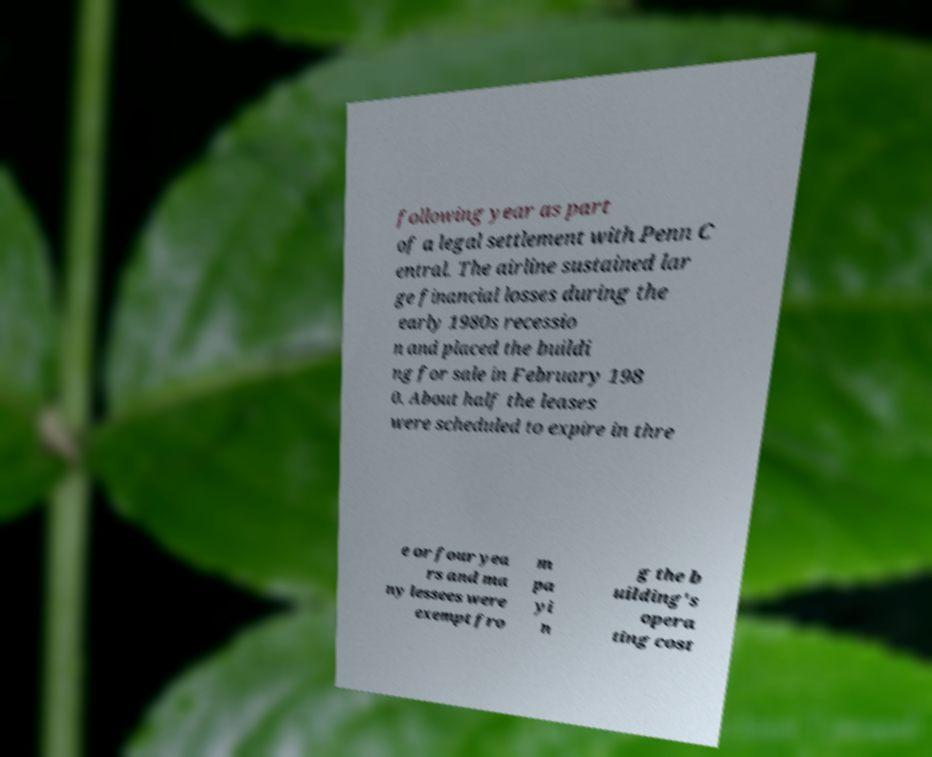Please identify and transcribe the text found in this image. following year as part of a legal settlement with Penn C entral. The airline sustained lar ge financial losses during the early 1980s recessio n and placed the buildi ng for sale in February 198 0. About half the leases were scheduled to expire in thre e or four yea rs and ma ny lessees were exempt fro m pa yi n g the b uilding's opera ting cost 